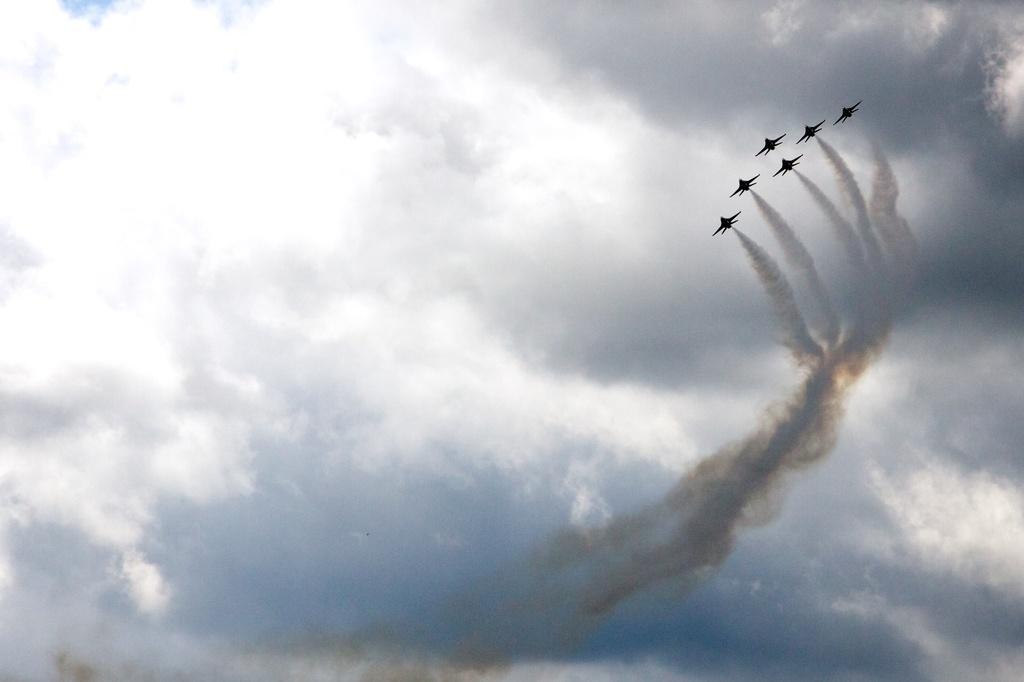Describe this image in one or two sentences. In this picture we can see airplanes flying, here we can see smoke and in the background we can see sky with clouds. 